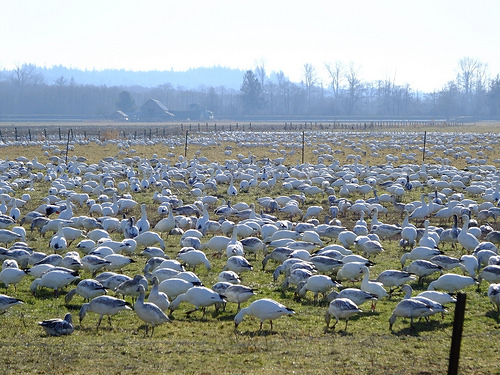<image>
Can you confirm if the bird is behind the other bird? No. The bird is not behind the other bird. From this viewpoint, the bird appears to be positioned elsewhere in the scene. 